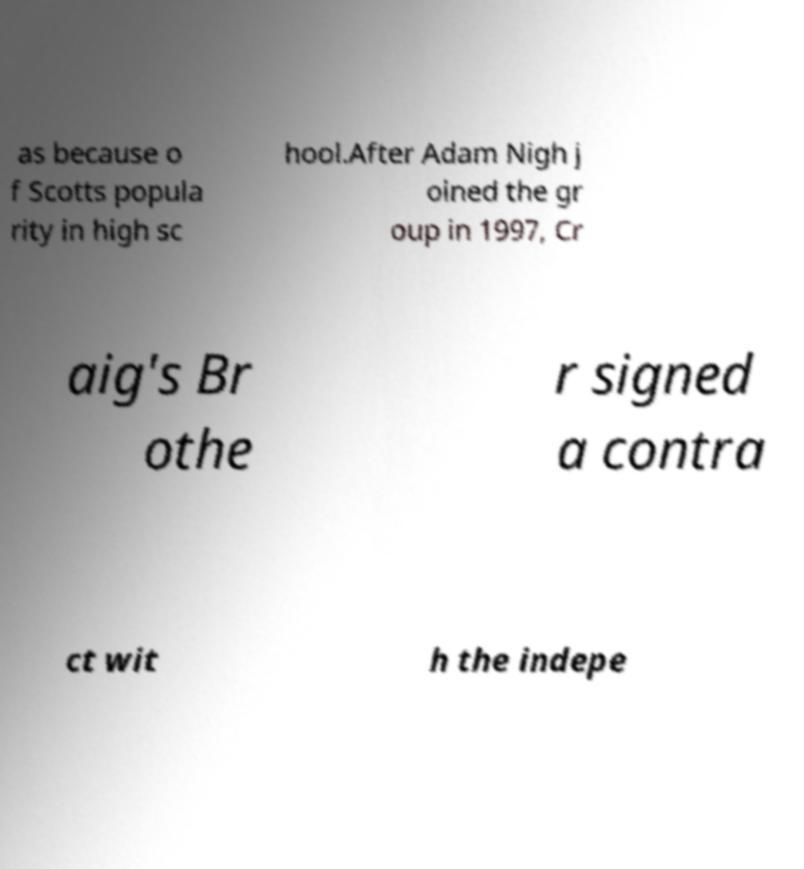What messages or text are displayed in this image? I need them in a readable, typed format. as because o f Scotts popula rity in high sc hool.After Adam Nigh j oined the gr oup in 1997, Cr aig's Br othe r signed a contra ct wit h the indepe 